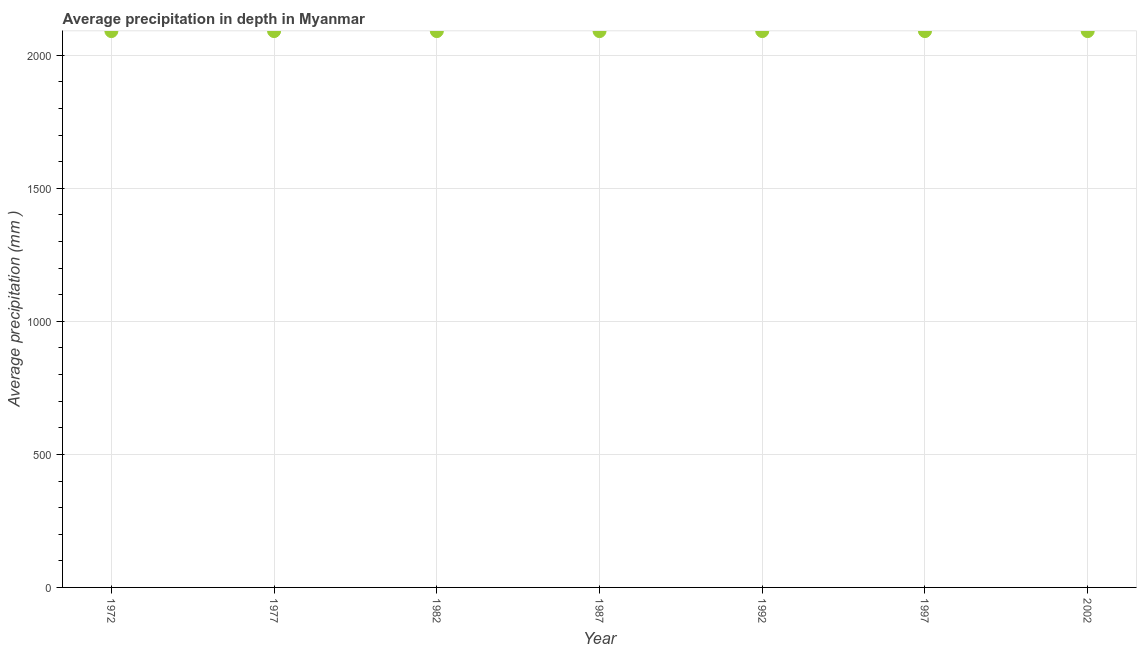What is the average precipitation in depth in 1982?
Make the answer very short. 2091. Across all years, what is the maximum average precipitation in depth?
Keep it short and to the point. 2091. Across all years, what is the minimum average precipitation in depth?
Ensure brevity in your answer.  2091. In which year was the average precipitation in depth maximum?
Provide a succinct answer. 1972. What is the sum of the average precipitation in depth?
Your answer should be very brief. 1.46e+04. What is the average average precipitation in depth per year?
Your answer should be compact. 2091. What is the median average precipitation in depth?
Keep it short and to the point. 2091. In how many years, is the average precipitation in depth greater than 200 mm?
Your answer should be compact. 7. Do a majority of the years between 1997 and 1977 (inclusive) have average precipitation in depth greater than 100 mm?
Provide a short and direct response. Yes. Is the difference between the average precipitation in depth in 1972 and 1977 greater than the difference between any two years?
Give a very brief answer. Yes. What is the difference between the highest and the second highest average precipitation in depth?
Provide a short and direct response. 0. What is the difference between the highest and the lowest average precipitation in depth?
Provide a short and direct response. 0. In how many years, is the average precipitation in depth greater than the average average precipitation in depth taken over all years?
Ensure brevity in your answer.  0. Does the average precipitation in depth monotonically increase over the years?
Your answer should be very brief. No. How many years are there in the graph?
Your answer should be very brief. 7. What is the difference between two consecutive major ticks on the Y-axis?
Your answer should be compact. 500. Does the graph contain any zero values?
Ensure brevity in your answer.  No. What is the title of the graph?
Your answer should be very brief. Average precipitation in depth in Myanmar. What is the label or title of the X-axis?
Provide a short and direct response. Year. What is the label or title of the Y-axis?
Your answer should be very brief. Average precipitation (mm ). What is the Average precipitation (mm ) in 1972?
Your response must be concise. 2091. What is the Average precipitation (mm ) in 1977?
Offer a terse response. 2091. What is the Average precipitation (mm ) in 1982?
Your answer should be very brief. 2091. What is the Average precipitation (mm ) in 1987?
Give a very brief answer. 2091. What is the Average precipitation (mm ) in 1992?
Make the answer very short. 2091. What is the Average precipitation (mm ) in 1997?
Your answer should be very brief. 2091. What is the Average precipitation (mm ) in 2002?
Ensure brevity in your answer.  2091. What is the difference between the Average precipitation (mm ) in 1972 and 1977?
Keep it short and to the point. 0. What is the difference between the Average precipitation (mm ) in 1972 and 1987?
Make the answer very short. 0. What is the difference between the Average precipitation (mm ) in 1972 and 1997?
Give a very brief answer. 0. What is the difference between the Average precipitation (mm ) in 1977 and 1987?
Your response must be concise. 0. What is the difference between the Average precipitation (mm ) in 1977 and 1992?
Make the answer very short. 0. What is the difference between the Average precipitation (mm ) in 1977 and 1997?
Ensure brevity in your answer.  0. What is the difference between the Average precipitation (mm ) in 1982 and 1992?
Give a very brief answer. 0. What is the difference between the Average precipitation (mm ) in 1982 and 2002?
Your response must be concise. 0. What is the difference between the Average precipitation (mm ) in 1987 and 1992?
Your answer should be very brief. 0. What is the difference between the Average precipitation (mm ) in 1987 and 2002?
Make the answer very short. 0. What is the difference between the Average precipitation (mm ) in 1992 and 1997?
Offer a very short reply. 0. What is the difference between the Average precipitation (mm ) in 1992 and 2002?
Offer a terse response. 0. What is the ratio of the Average precipitation (mm ) in 1972 to that in 1977?
Make the answer very short. 1. What is the ratio of the Average precipitation (mm ) in 1972 to that in 1982?
Ensure brevity in your answer.  1. What is the ratio of the Average precipitation (mm ) in 1972 to that in 1987?
Give a very brief answer. 1. What is the ratio of the Average precipitation (mm ) in 1972 to that in 1992?
Make the answer very short. 1. What is the ratio of the Average precipitation (mm ) in 1977 to that in 1982?
Make the answer very short. 1. What is the ratio of the Average precipitation (mm ) in 1977 to that in 1987?
Your answer should be very brief. 1. What is the ratio of the Average precipitation (mm ) in 1977 to that in 1992?
Your response must be concise. 1. What is the ratio of the Average precipitation (mm ) in 1982 to that in 1992?
Your response must be concise. 1. What is the ratio of the Average precipitation (mm ) in 1987 to that in 1992?
Your answer should be very brief. 1. What is the ratio of the Average precipitation (mm ) in 1987 to that in 1997?
Give a very brief answer. 1. What is the ratio of the Average precipitation (mm ) in 1987 to that in 2002?
Your answer should be compact. 1. What is the ratio of the Average precipitation (mm ) in 1997 to that in 2002?
Keep it short and to the point. 1. 